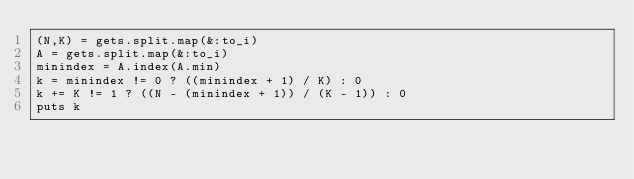<code> <loc_0><loc_0><loc_500><loc_500><_Ruby_>(N,K) = gets.split.map(&:to_i)
A = gets.split.map(&:to_i)
minindex = A.index(A.min)
k = minindex != 0 ? ((minindex + 1) / K) : 0
k += K != 1 ? ((N - (minindex + 1)) / (K - 1)) : 0
puts k</code> 